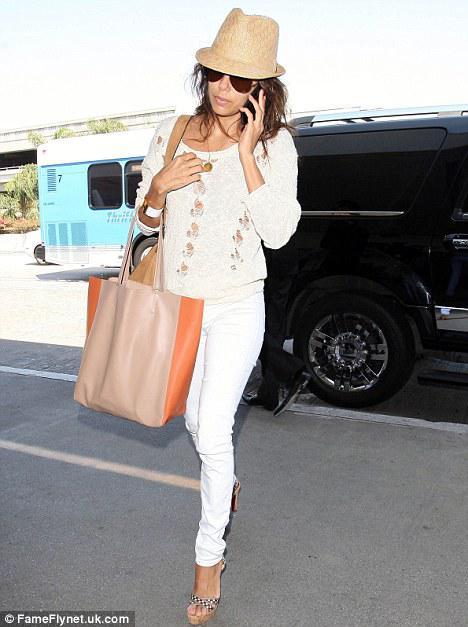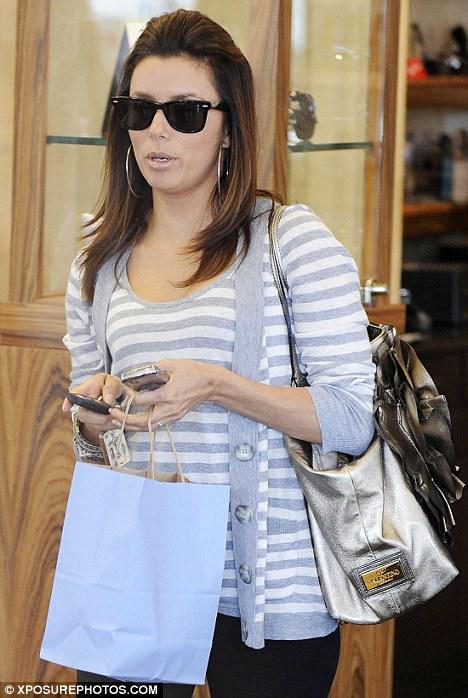The first image is the image on the left, the second image is the image on the right. For the images shown, is this caption "Exactly one woman is talking on her phone." true? Answer yes or no. Yes. 